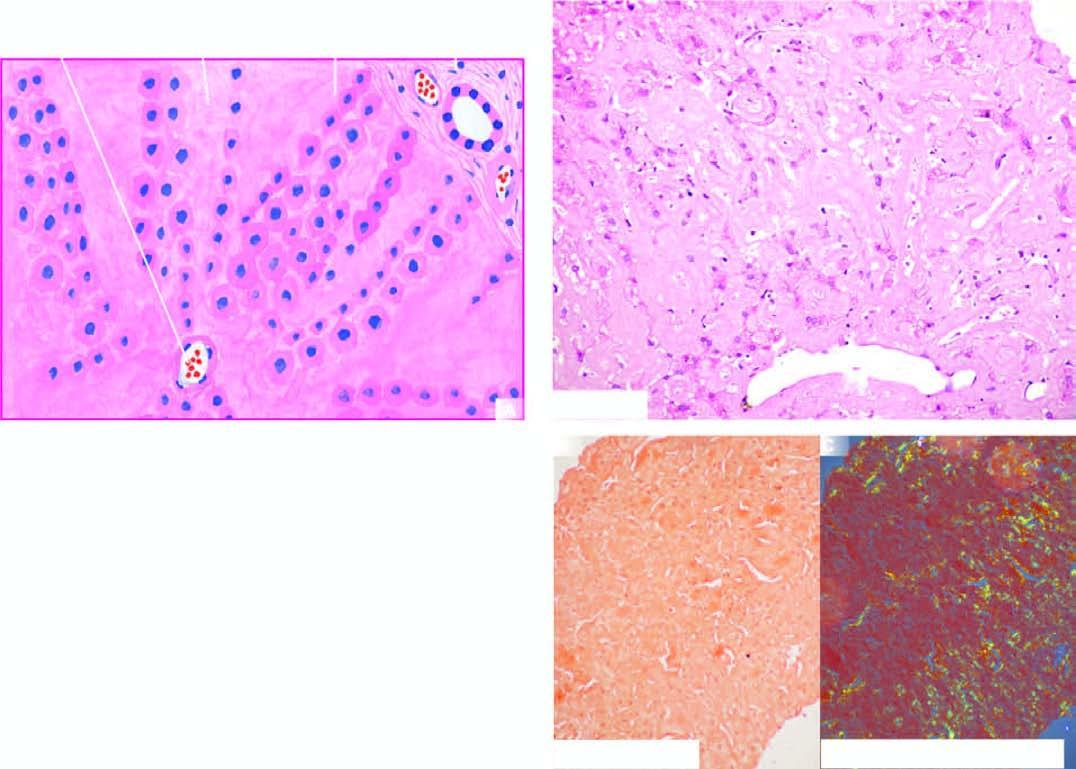s the surrounding zone extensive in the space of disse causing compression and pressure atrophy of hepatocytes?
Answer the question using a single word or phrase. No 